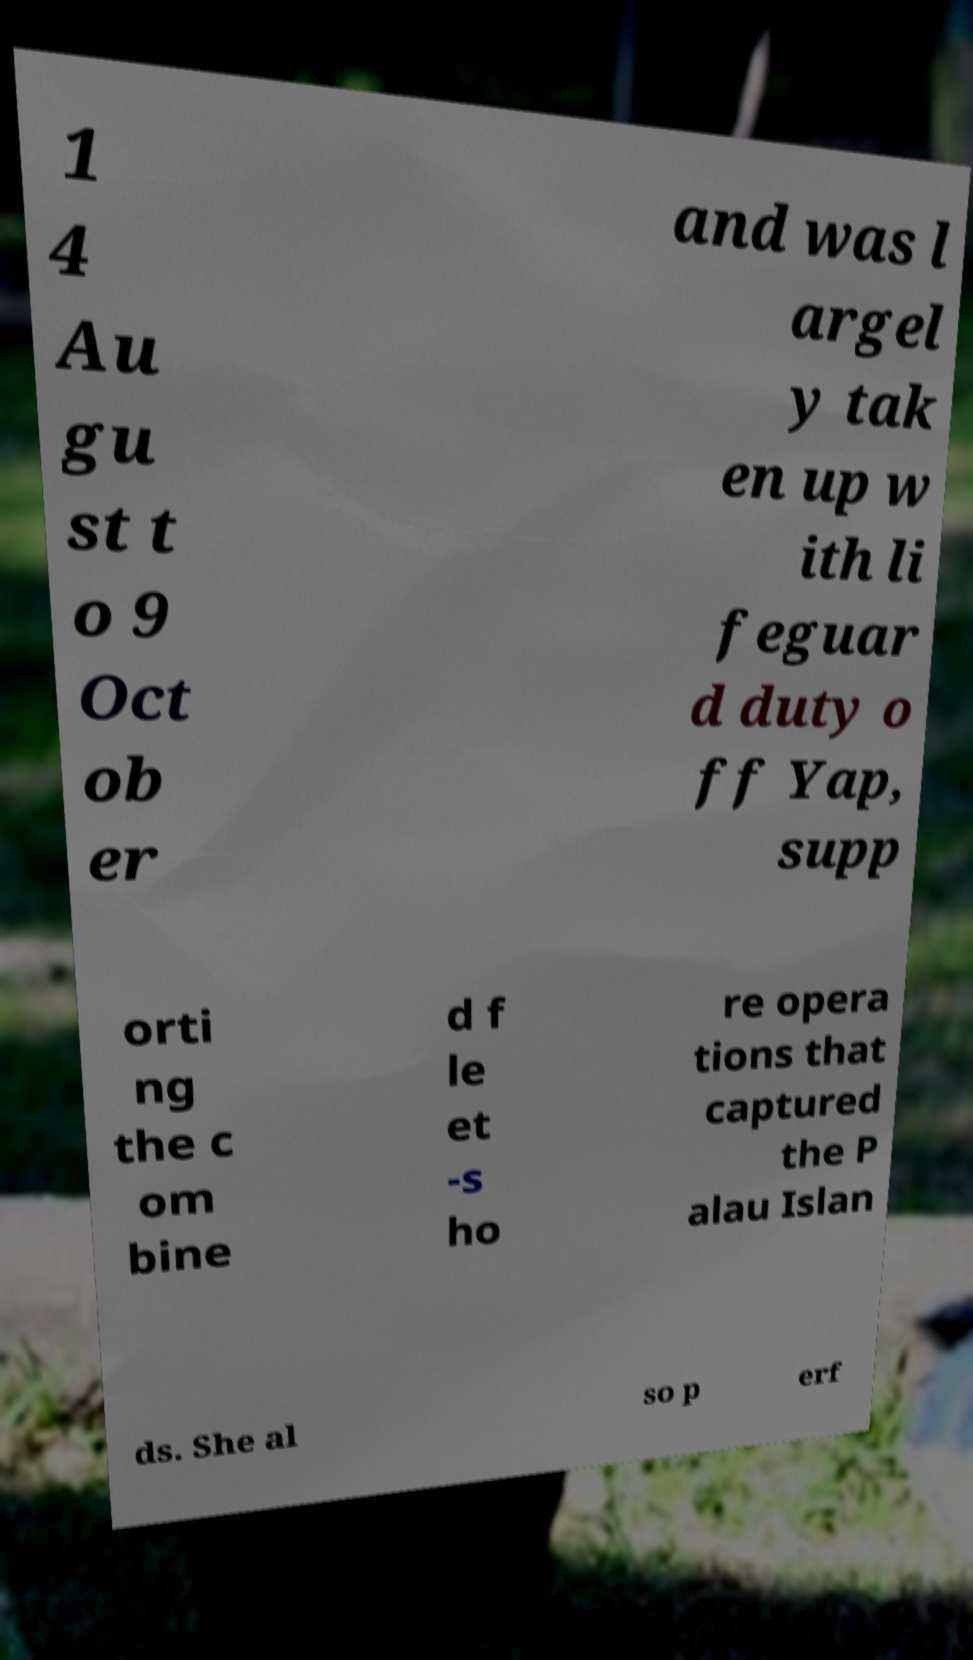Can you read and provide the text displayed in the image?This photo seems to have some interesting text. Can you extract and type it out for me? 1 4 Au gu st t o 9 Oct ob er and was l argel y tak en up w ith li feguar d duty o ff Yap, supp orti ng the c om bine d f le et -s ho re opera tions that captured the P alau Islan ds. She al so p erf 